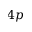<formula> <loc_0><loc_0><loc_500><loc_500>4 p</formula> 